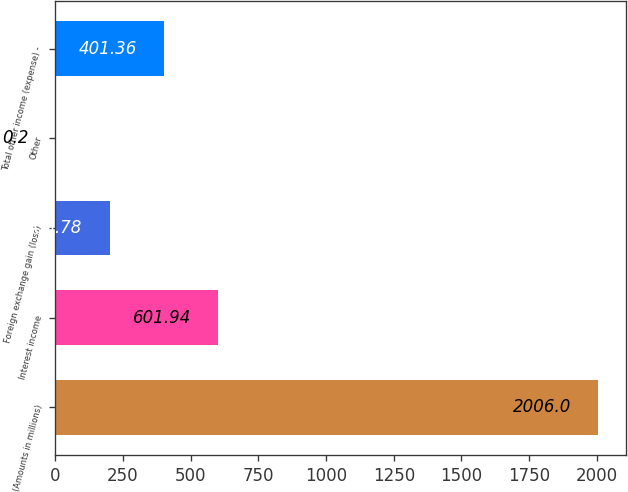Convert chart to OTSL. <chart><loc_0><loc_0><loc_500><loc_500><bar_chart><fcel>(Amounts in millions)<fcel>Interest income<fcel>Foreign exchange gain (loss)<fcel>Other<fcel>Total other income (expense) -<nl><fcel>2006<fcel>601.94<fcel>200.78<fcel>0.2<fcel>401.36<nl></chart> 